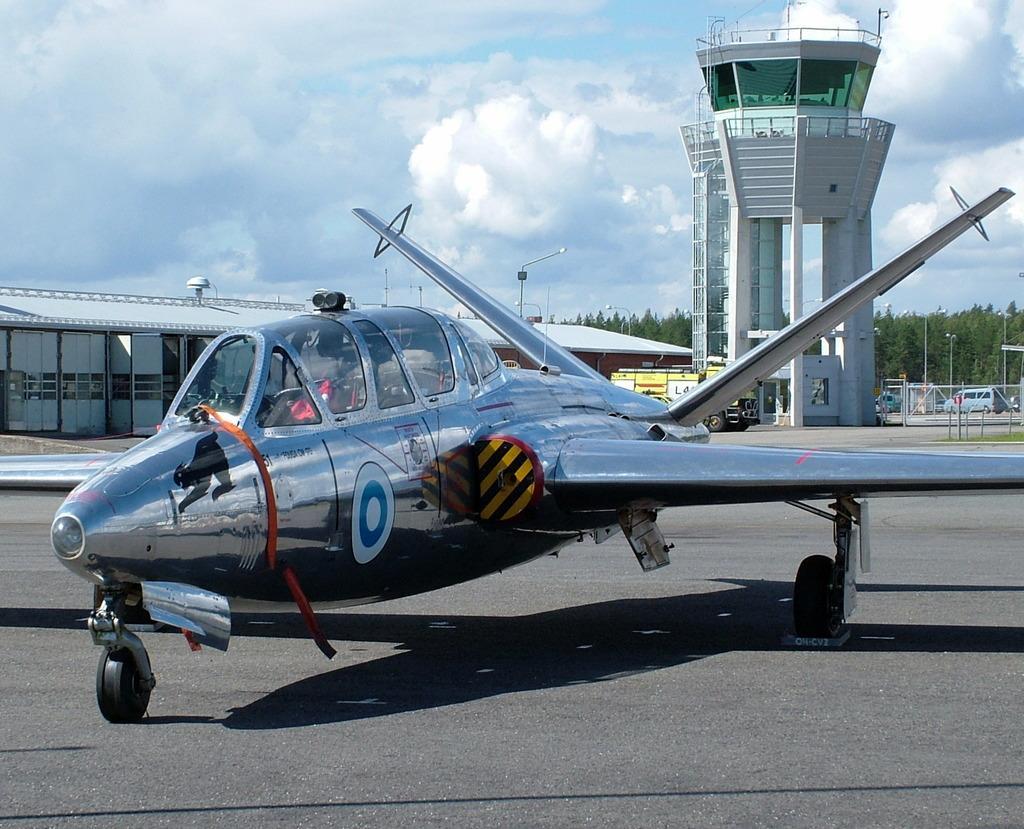Describe this image in one or two sentences. In this image in the center there is a airplane, and in the background there are some towers, trees, poles, lights. And on the right side there is a car and railing, at the bottom there is road and at the top of the image there is sky. 